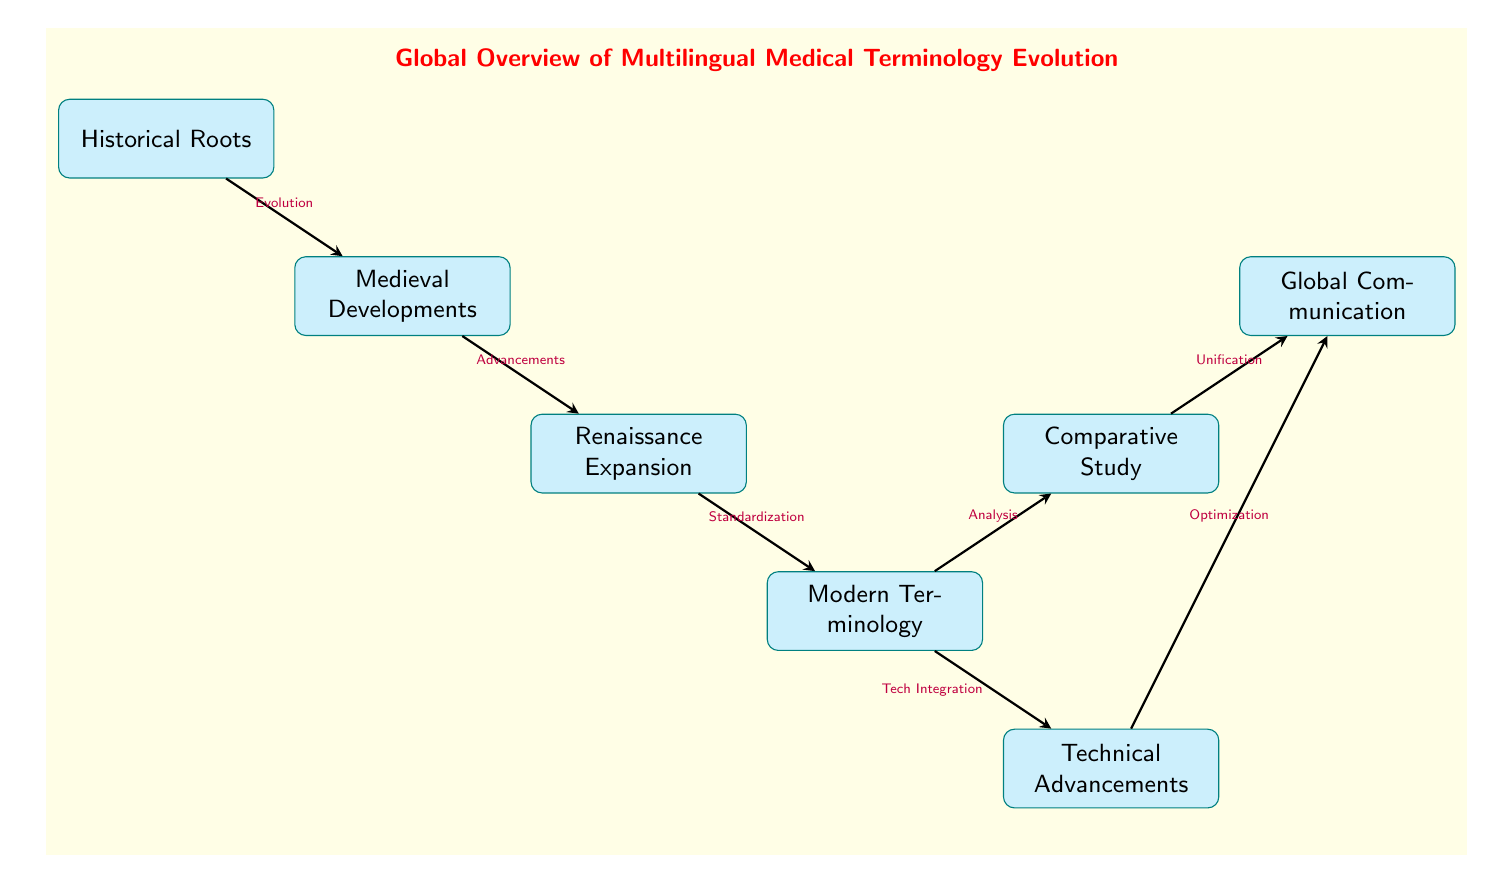What is the first node in the diagram? The first node in the diagram is "Historical Roots," which is positioned at the top and serves as the starting point for the evolution of multilingual medical terminology.
Answer: Historical Roots How many nodes are in the diagram? To find the total number of nodes, I count all the named nodes in the diagram. There are seven nodes listed: Historical Roots, Medieval Developments, Renaissance Expansion, Modern Terminology, Comparative Study, Global Communication, and Technical Advancements.
Answer: 7 What is the relationship between "Modern Terminology" and "Comparative Study"? The relationship indicated in the diagram shows that "Modern Terminology" leads to "Comparative Study" through the edge labeled "Analysis." This indicates that after modern terms are established, they are analyzed for comparative purposes.
Answer: Analysis Which node represents the advancements from the Medieval period? The node that represents advancements stemming from the Medieval period is "Medieval Developments." This node follows the "Historical Roots" node in the evolutionary path of medical terminology.
Answer: Medieval Developments What two nodes connect to "Global Communication"? The two nodes connecting to "Global Communication" are "Comparative Study" and "Technical Advancements." "Comparative Study" connects through "Unification," while "Technical Advancements" connects through "Optimization."
Answer: Comparative Study, Technical Advancements What is the last step in the evolution of medical terminology as shown in the diagram? The last step in the evolution is "Global Communication," which is reached after the node "Comparative Study" and one other node. It signifies the end goal of unifying multilingual medical terminology for better communication globally.
Answer: Global Communication What does the edge from "Modern Terminology" to "Technical Advancements" indicate? The edge labeled "Tech Integration" from "Modern Terminology" to "Technical Advancements" indicates that the integration of technology plays a significant role in the development and standardization of modern medical terminology.
Answer: Tech Integration Which node describes the period of growth following the Medieval times? The node that describes the period of growth after the Medieval times is "Renaissance Expansion." This node follows "Medieval Developments" and reflects the advancements in medical terminology during the Renaissance.
Answer: Renaissance Expansion 